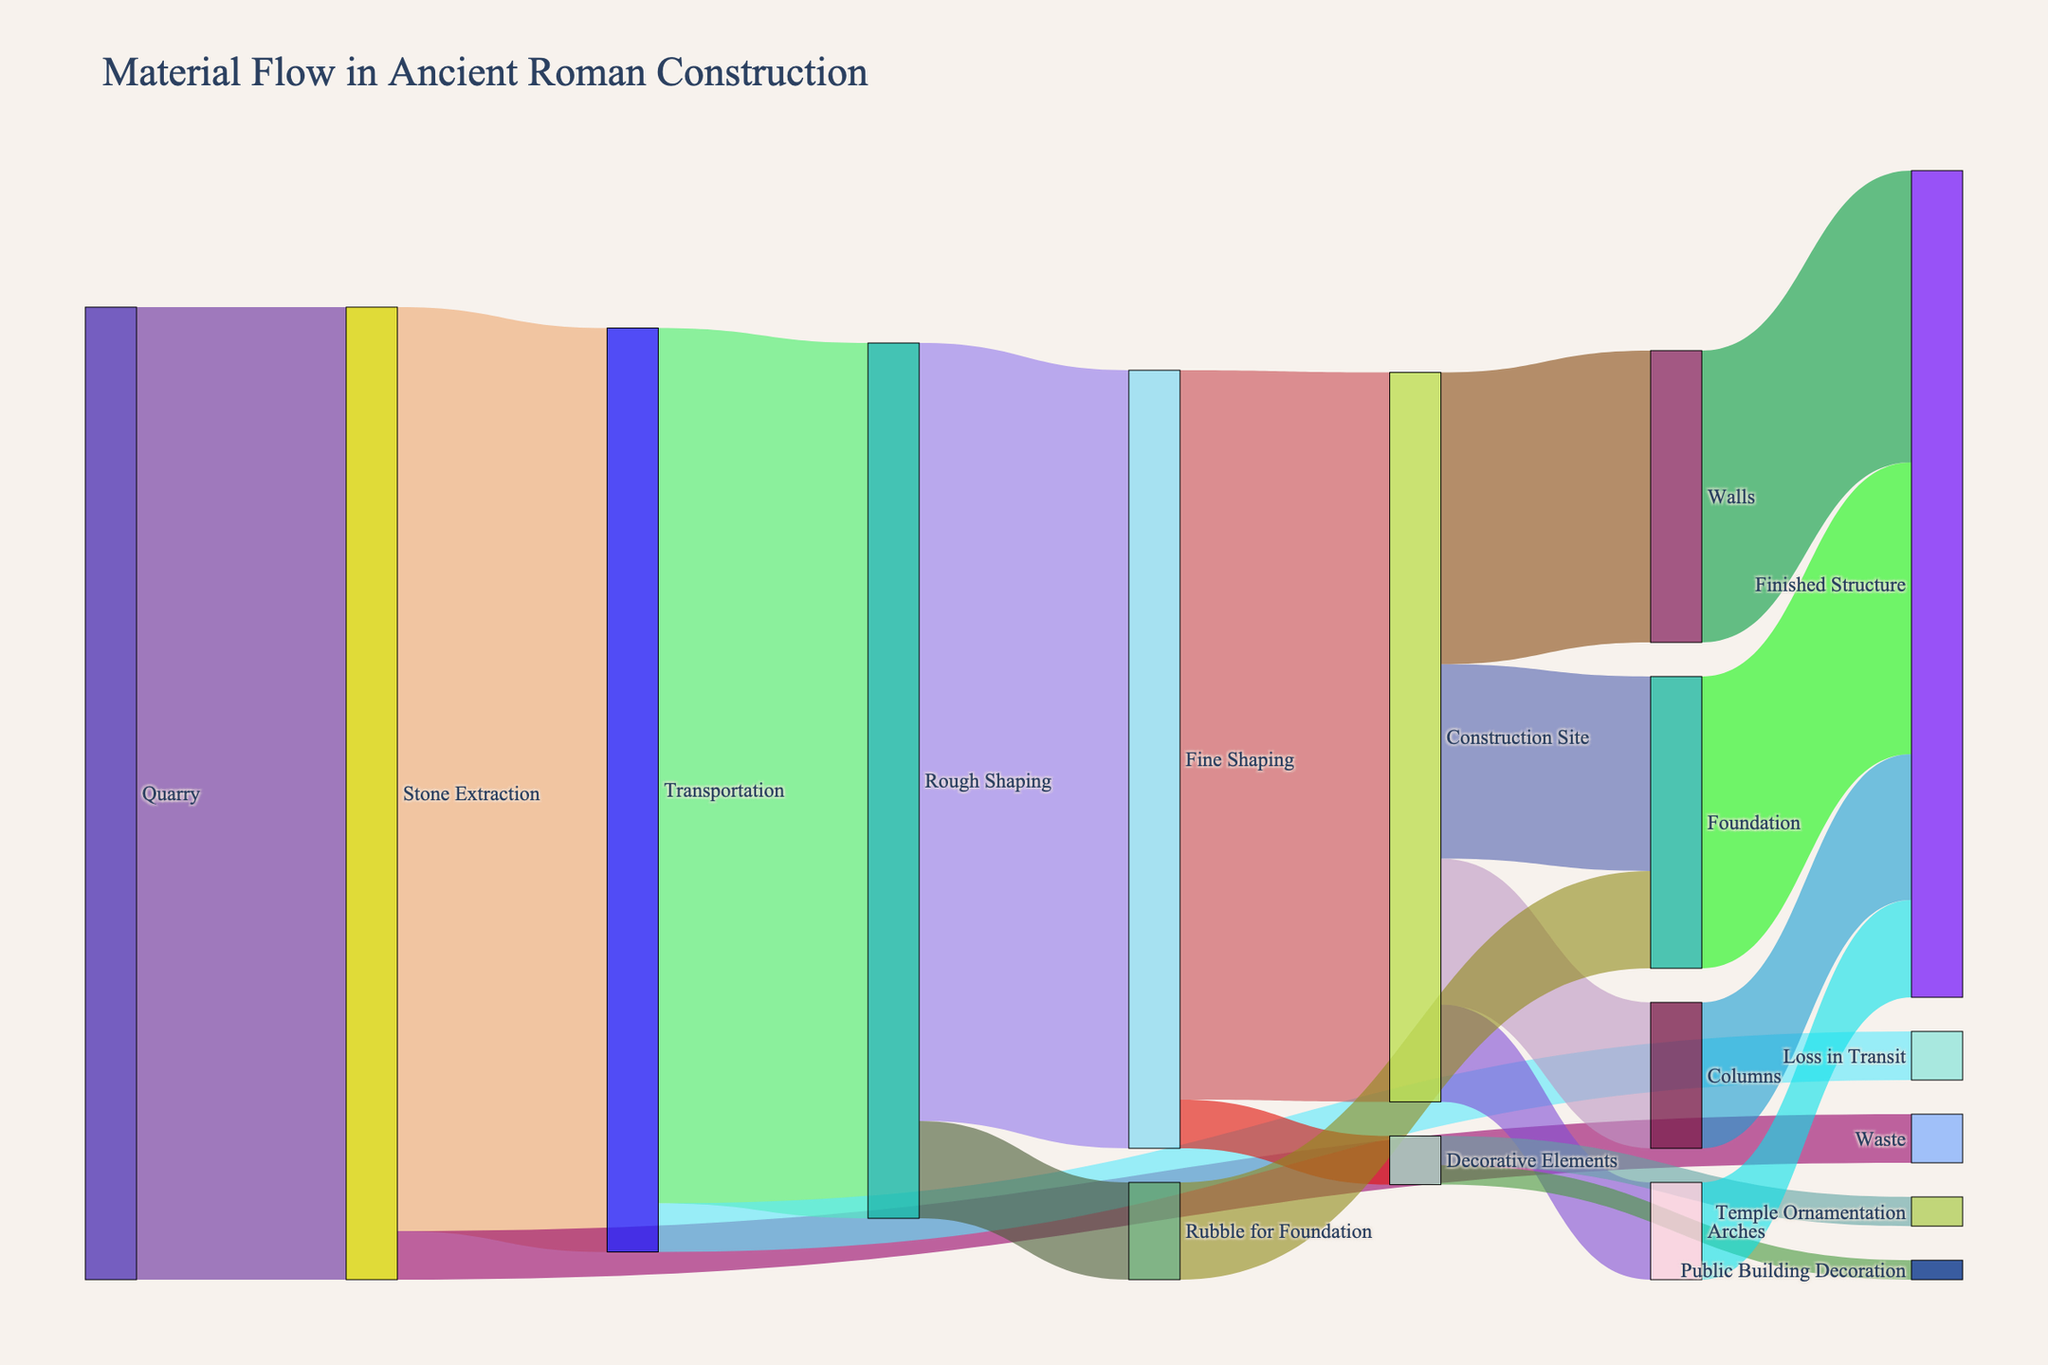what is the title of the diagram? The title is usually found at the top of the diagram and provides an overview of what the diagram represents. In this case, the title is: "Material Flow in Ancient Roman Construction".
Answer: Material Flow in Ancient Roman Construction How much material is lost during the Stone Extraction stage? Look for sections of the diagram labeled 'Stone Extraction' and check the values flowing from it. We see that 5 units go to 'Waste'.
Answer: 5 What is the total material that reaches the Construction Site? Sum the material flowing into 'Construction Site'. We have 75 from 'Fine Shaping' + 10 from 'Rubble for Foundation'.
Answer: 75 Compare the amounts of material going to Temple Ornamentation and Public Building Decoration. Which one receives more? Check the values flowing to 'Temple Ornamentation' and 'Public Building Decoration'. 3 units go to 'Temple Ornamentation' and 2 units go to 'Public Building Decoration'.
Answer: Temple Ornamentation Which process has the largest material flow from Transportation? Check the flows coming out of 'Transportation'. 'Rough Shaping' receives 90 units, 'Loss in Transit' receives 5 units. The larger flow is to 'Rough Shaping'.
Answer: Rough Shaping What is the sum of material used for Foundation and Walls at the Construction Site? Sum the material flows labeled 'Foundation' and 'Walls' under 'Construction Site'. 20 units go to 'Foundation' and 30 units go to 'Walls'.
Answer: 50 How much material is used for the entire Finished Structure? Add all material flows to 'Finished Structure'. Foundation (30) + Walls (30) + Columns (15) + Arches (10).
Answer: 85 Explain how material flows from Rough Shaping to the final stages. Start from 'Rough Shaping' and follow the paths. 80 units go to 'Fine Shaping', which then splits into 'Construction Site' (75) and 'Decorative Elements' (5). From 'Construction Site', the flow splits into 'Foundation', 'Walls', 'Columns', and 'Arches', eventually all summing up in 'Finished Structure'.
Answer: Rough Shaping → Fine Shaping → Construction Site → Finished Structure Identify two stages where material is lost or reduced in volume. Inspect the Sankey diagram for any losses or reductions. First, at 'Stone Extraction' to 'Waste' (5 units), and second, at 'Transportation' to 'Loss in Transit' (5 units).
Answer: Stone Extraction, Transportation 